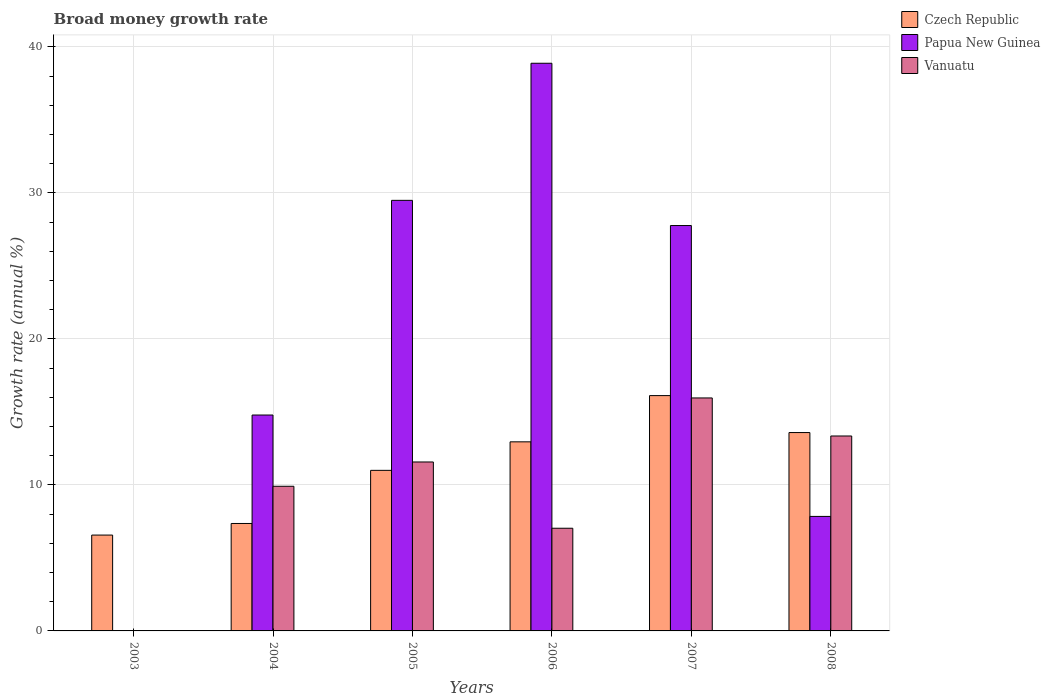Are the number of bars per tick equal to the number of legend labels?
Provide a short and direct response. No. Are the number of bars on each tick of the X-axis equal?
Offer a very short reply. No. How many bars are there on the 4th tick from the left?
Keep it short and to the point. 3. How many bars are there on the 5th tick from the right?
Keep it short and to the point. 3. What is the label of the 3rd group of bars from the left?
Provide a succinct answer. 2005. In how many cases, is the number of bars for a given year not equal to the number of legend labels?
Offer a very short reply. 1. What is the growth rate in Czech Republic in 2006?
Provide a succinct answer. 12.95. Across all years, what is the maximum growth rate in Czech Republic?
Make the answer very short. 16.12. Across all years, what is the minimum growth rate in Vanuatu?
Give a very brief answer. 0. What is the total growth rate in Papua New Guinea in the graph?
Offer a very short reply. 118.76. What is the difference between the growth rate in Vanuatu in 2004 and that in 2006?
Your answer should be very brief. 2.87. What is the difference between the growth rate in Papua New Guinea in 2007 and the growth rate in Czech Republic in 2005?
Make the answer very short. 16.77. What is the average growth rate in Papua New Guinea per year?
Offer a terse response. 19.79. In the year 2004, what is the difference between the growth rate in Vanuatu and growth rate in Czech Republic?
Your answer should be compact. 2.55. What is the ratio of the growth rate in Vanuatu in 2006 to that in 2008?
Give a very brief answer. 0.53. Is the difference between the growth rate in Vanuatu in 2005 and 2006 greater than the difference between the growth rate in Czech Republic in 2005 and 2006?
Ensure brevity in your answer.  Yes. What is the difference between the highest and the second highest growth rate in Papua New Guinea?
Make the answer very short. 9.39. What is the difference between the highest and the lowest growth rate in Czech Republic?
Your answer should be very brief. 9.55. In how many years, is the growth rate in Papua New Guinea greater than the average growth rate in Papua New Guinea taken over all years?
Your answer should be compact. 3. Is the sum of the growth rate in Papua New Guinea in 2005 and 2006 greater than the maximum growth rate in Vanuatu across all years?
Give a very brief answer. Yes. Is it the case that in every year, the sum of the growth rate in Vanuatu and growth rate in Czech Republic is greater than the growth rate in Papua New Guinea?
Ensure brevity in your answer.  No. Are all the bars in the graph horizontal?
Make the answer very short. No. What is the difference between two consecutive major ticks on the Y-axis?
Your answer should be compact. 10. Are the values on the major ticks of Y-axis written in scientific E-notation?
Your response must be concise. No. Does the graph contain grids?
Keep it short and to the point. Yes. How many legend labels are there?
Ensure brevity in your answer.  3. What is the title of the graph?
Keep it short and to the point. Broad money growth rate. What is the label or title of the Y-axis?
Your answer should be compact. Growth rate (annual %). What is the Growth rate (annual %) in Czech Republic in 2003?
Provide a short and direct response. 6.56. What is the Growth rate (annual %) of Papua New Guinea in 2003?
Provide a short and direct response. 0. What is the Growth rate (annual %) of Czech Republic in 2004?
Provide a short and direct response. 7.36. What is the Growth rate (annual %) in Papua New Guinea in 2004?
Ensure brevity in your answer.  14.79. What is the Growth rate (annual %) of Vanuatu in 2004?
Make the answer very short. 9.91. What is the Growth rate (annual %) in Czech Republic in 2005?
Your answer should be compact. 11. What is the Growth rate (annual %) in Papua New Guinea in 2005?
Give a very brief answer. 29.49. What is the Growth rate (annual %) of Vanuatu in 2005?
Give a very brief answer. 11.57. What is the Growth rate (annual %) of Czech Republic in 2006?
Give a very brief answer. 12.95. What is the Growth rate (annual %) of Papua New Guinea in 2006?
Make the answer very short. 38.88. What is the Growth rate (annual %) of Vanuatu in 2006?
Make the answer very short. 7.03. What is the Growth rate (annual %) in Czech Republic in 2007?
Make the answer very short. 16.12. What is the Growth rate (annual %) in Papua New Guinea in 2007?
Offer a terse response. 27.76. What is the Growth rate (annual %) in Vanuatu in 2007?
Offer a terse response. 15.96. What is the Growth rate (annual %) in Czech Republic in 2008?
Ensure brevity in your answer.  13.59. What is the Growth rate (annual %) of Papua New Guinea in 2008?
Provide a succinct answer. 7.84. What is the Growth rate (annual %) of Vanuatu in 2008?
Your response must be concise. 13.35. Across all years, what is the maximum Growth rate (annual %) of Czech Republic?
Ensure brevity in your answer.  16.12. Across all years, what is the maximum Growth rate (annual %) in Papua New Guinea?
Keep it short and to the point. 38.88. Across all years, what is the maximum Growth rate (annual %) in Vanuatu?
Your response must be concise. 15.96. Across all years, what is the minimum Growth rate (annual %) in Czech Republic?
Keep it short and to the point. 6.56. Across all years, what is the minimum Growth rate (annual %) in Papua New Guinea?
Your response must be concise. 0. Across all years, what is the minimum Growth rate (annual %) of Vanuatu?
Keep it short and to the point. 0. What is the total Growth rate (annual %) of Czech Republic in the graph?
Your response must be concise. 67.58. What is the total Growth rate (annual %) in Papua New Guinea in the graph?
Your answer should be compact. 118.76. What is the total Growth rate (annual %) of Vanuatu in the graph?
Give a very brief answer. 57.82. What is the difference between the Growth rate (annual %) in Czech Republic in 2003 and that in 2004?
Make the answer very short. -0.79. What is the difference between the Growth rate (annual %) in Czech Republic in 2003 and that in 2005?
Ensure brevity in your answer.  -4.43. What is the difference between the Growth rate (annual %) of Czech Republic in 2003 and that in 2006?
Your answer should be compact. -6.39. What is the difference between the Growth rate (annual %) of Czech Republic in 2003 and that in 2007?
Your response must be concise. -9.55. What is the difference between the Growth rate (annual %) of Czech Republic in 2003 and that in 2008?
Offer a very short reply. -7.02. What is the difference between the Growth rate (annual %) in Czech Republic in 2004 and that in 2005?
Provide a short and direct response. -3.64. What is the difference between the Growth rate (annual %) in Papua New Guinea in 2004 and that in 2005?
Offer a terse response. -14.7. What is the difference between the Growth rate (annual %) in Vanuatu in 2004 and that in 2005?
Provide a short and direct response. -1.66. What is the difference between the Growth rate (annual %) of Czech Republic in 2004 and that in 2006?
Provide a short and direct response. -5.59. What is the difference between the Growth rate (annual %) of Papua New Guinea in 2004 and that in 2006?
Ensure brevity in your answer.  -24.09. What is the difference between the Growth rate (annual %) of Vanuatu in 2004 and that in 2006?
Make the answer very short. 2.87. What is the difference between the Growth rate (annual %) of Czech Republic in 2004 and that in 2007?
Make the answer very short. -8.76. What is the difference between the Growth rate (annual %) of Papua New Guinea in 2004 and that in 2007?
Provide a short and direct response. -12.98. What is the difference between the Growth rate (annual %) of Vanuatu in 2004 and that in 2007?
Offer a very short reply. -6.05. What is the difference between the Growth rate (annual %) in Czech Republic in 2004 and that in 2008?
Your answer should be very brief. -6.23. What is the difference between the Growth rate (annual %) in Papua New Guinea in 2004 and that in 2008?
Give a very brief answer. 6.94. What is the difference between the Growth rate (annual %) in Vanuatu in 2004 and that in 2008?
Ensure brevity in your answer.  -3.44. What is the difference between the Growth rate (annual %) in Czech Republic in 2005 and that in 2006?
Offer a terse response. -1.95. What is the difference between the Growth rate (annual %) of Papua New Guinea in 2005 and that in 2006?
Make the answer very short. -9.39. What is the difference between the Growth rate (annual %) of Vanuatu in 2005 and that in 2006?
Give a very brief answer. 4.54. What is the difference between the Growth rate (annual %) in Czech Republic in 2005 and that in 2007?
Provide a succinct answer. -5.12. What is the difference between the Growth rate (annual %) of Papua New Guinea in 2005 and that in 2007?
Provide a succinct answer. 1.73. What is the difference between the Growth rate (annual %) of Vanuatu in 2005 and that in 2007?
Your answer should be very brief. -4.38. What is the difference between the Growth rate (annual %) of Czech Republic in 2005 and that in 2008?
Your answer should be very brief. -2.59. What is the difference between the Growth rate (annual %) in Papua New Guinea in 2005 and that in 2008?
Your answer should be compact. 21.65. What is the difference between the Growth rate (annual %) of Vanuatu in 2005 and that in 2008?
Offer a very short reply. -1.78. What is the difference between the Growth rate (annual %) of Czech Republic in 2006 and that in 2007?
Offer a very short reply. -3.17. What is the difference between the Growth rate (annual %) in Papua New Guinea in 2006 and that in 2007?
Give a very brief answer. 11.11. What is the difference between the Growth rate (annual %) in Vanuatu in 2006 and that in 2007?
Offer a very short reply. -8.92. What is the difference between the Growth rate (annual %) in Czech Republic in 2006 and that in 2008?
Your answer should be compact. -0.64. What is the difference between the Growth rate (annual %) of Papua New Guinea in 2006 and that in 2008?
Your answer should be very brief. 31.04. What is the difference between the Growth rate (annual %) in Vanuatu in 2006 and that in 2008?
Provide a succinct answer. -6.32. What is the difference between the Growth rate (annual %) in Czech Republic in 2007 and that in 2008?
Your answer should be compact. 2.53. What is the difference between the Growth rate (annual %) in Papua New Guinea in 2007 and that in 2008?
Your response must be concise. 19.92. What is the difference between the Growth rate (annual %) of Vanuatu in 2007 and that in 2008?
Your response must be concise. 2.61. What is the difference between the Growth rate (annual %) of Czech Republic in 2003 and the Growth rate (annual %) of Papua New Guinea in 2004?
Keep it short and to the point. -8.22. What is the difference between the Growth rate (annual %) in Czech Republic in 2003 and the Growth rate (annual %) in Vanuatu in 2004?
Keep it short and to the point. -3.34. What is the difference between the Growth rate (annual %) of Czech Republic in 2003 and the Growth rate (annual %) of Papua New Guinea in 2005?
Keep it short and to the point. -22.93. What is the difference between the Growth rate (annual %) of Czech Republic in 2003 and the Growth rate (annual %) of Vanuatu in 2005?
Keep it short and to the point. -5.01. What is the difference between the Growth rate (annual %) in Czech Republic in 2003 and the Growth rate (annual %) in Papua New Guinea in 2006?
Your response must be concise. -32.31. What is the difference between the Growth rate (annual %) of Czech Republic in 2003 and the Growth rate (annual %) of Vanuatu in 2006?
Your response must be concise. -0.47. What is the difference between the Growth rate (annual %) in Czech Republic in 2003 and the Growth rate (annual %) in Papua New Guinea in 2007?
Give a very brief answer. -21.2. What is the difference between the Growth rate (annual %) in Czech Republic in 2003 and the Growth rate (annual %) in Vanuatu in 2007?
Offer a terse response. -9.39. What is the difference between the Growth rate (annual %) in Czech Republic in 2003 and the Growth rate (annual %) in Papua New Guinea in 2008?
Give a very brief answer. -1.28. What is the difference between the Growth rate (annual %) of Czech Republic in 2003 and the Growth rate (annual %) of Vanuatu in 2008?
Provide a short and direct response. -6.79. What is the difference between the Growth rate (annual %) of Czech Republic in 2004 and the Growth rate (annual %) of Papua New Guinea in 2005?
Provide a short and direct response. -22.13. What is the difference between the Growth rate (annual %) of Czech Republic in 2004 and the Growth rate (annual %) of Vanuatu in 2005?
Ensure brevity in your answer.  -4.21. What is the difference between the Growth rate (annual %) of Papua New Guinea in 2004 and the Growth rate (annual %) of Vanuatu in 2005?
Offer a terse response. 3.22. What is the difference between the Growth rate (annual %) of Czech Republic in 2004 and the Growth rate (annual %) of Papua New Guinea in 2006?
Provide a short and direct response. -31.52. What is the difference between the Growth rate (annual %) in Czech Republic in 2004 and the Growth rate (annual %) in Vanuatu in 2006?
Your response must be concise. 0.33. What is the difference between the Growth rate (annual %) in Papua New Guinea in 2004 and the Growth rate (annual %) in Vanuatu in 2006?
Your answer should be very brief. 7.75. What is the difference between the Growth rate (annual %) of Czech Republic in 2004 and the Growth rate (annual %) of Papua New Guinea in 2007?
Offer a terse response. -20.41. What is the difference between the Growth rate (annual %) in Czech Republic in 2004 and the Growth rate (annual %) in Vanuatu in 2007?
Provide a short and direct response. -8.6. What is the difference between the Growth rate (annual %) of Papua New Guinea in 2004 and the Growth rate (annual %) of Vanuatu in 2007?
Keep it short and to the point. -1.17. What is the difference between the Growth rate (annual %) in Czech Republic in 2004 and the Growth rate (annual %) in Papua New Guinea in 2008?
Provide a short and direct response. -0.48. What is the difference between the Growth rate (annual %) of Czech Republic in 2004 and the Growth rate (annual %) of Vanuatu in 2008?
Ensure brevity in your answer.  -5.99. What is the difference between the Growth rate (annual %) in Papua New Guinea in 2004 and the Growth rate (annual %) in Vanuatu in 2008?
Your response must be concise. 1.44. What is the difference between the Growth rate (annual %) in Czech Republic in 2005 and the Growth rate (annual %) in Papua New Guinea in 2006?
Your answer should be very brief. -27.88. What is the difference between the Growth rate (annual %) in Czech Republic in 2005 and the Growth rate (annual %) in Vanuatu in 2006?
Your answer should be compact. 3.96. What is the difference between the Growth rate (annual %) of Papua New Guinea in 2005 and the Growth rate (annual %) of Vanuatu in 2006?
Your response must be concise. 22.46. What is the difference between the Growth rate (annual %) of Czech Republic in 2005 and the Growth rate (annual %) of Papua New Guinea in 2007?
Offer a terse response. -16.77. What is the difference between the Growth rate (annual %) of Czech Republic in 2005 and the Growth rate (annual %) of Vanuatu in 2007?
Give a very brief answer. -4.96. What is the difference between the Growth rate (annual %) of Papua New Guinea in 2005 and the Growth rate (annual %) of Vanuatu in 2007?
Your answer should be compact. 13.53. What is the difference between the Growth rate (annual %) of Czech Republic in 2005 and the Growth rate (annual %) of Papua New Guinea in 2008?
Offer a terse response. 3.15. What is the difference between the Growth rate (annual %) in Czech Republic in 2005 and the Growth rate (annual %) in Vanuatu in 2008?
Keep it short and to the point. -2.35. What is the difference between the Growth rate (annual %) of Papua New Guinea in 2005 and the Growth rate (annual %) of Vanuatu in 2008?
Provide a short and direct response. 16.14. What is the difference between the Growth rate (annual %) in Czech Republic in 2006 and the Growth rate (annual %) in Papua New Guinea in 2007?
Your answer should be very brief. -14.81. What is the difference between the Growth rate (annual %) in Czech Republic in 2006 and the Growth rate (annual %) in Vanuatu in 2007?
Keep it short and to the point. -3.01. What is the difference between the Growth rate (annual %) of Papua New Guinea in 2006 and the Growth rate (annual %) of Vanuatu in 2007?
Keep it short and to the point. 22.92. What is the difference between the Growth rate (annual %) in Czech Republic in 2006 and the Growth rate (annual %) in Papua New Guinea in 2008?
Keep it short and to the point. 5.11. What is the difference between the Growth rate (annual %) of Czech Republic in 2006 and the Growth rate (annual %) of Vanuatu in 2008?
Offer a terse response. -0.4. What is the difference between the Growth rate (annual %) of Papua New Guinea in 2006 and the Growth rate (annual %) of Vanuatu in 2008?
Offer a very short reply. 25.53. What is the difference between the Growth rate (annual %) of Czech Republic in 2007 and the Growth rate (annual %) of Papua New Guinea in 2008?
Make the answer very short. 8.27. What is the difference between the Growth rate (annual %) in Czech Republic in 2007 and the Growth rate (annual %) in Vanuatu in 2008?
Offer a very short reply. 2.77. What is the difference between the Growth rate (annual %) of Papua New Guinea in 2007 and the Growth rate (annual %) of Vanuatu in 2008?
Give a very brief answer. 14.41. What is the average Growth rate (annual %) of Czech Republic per year?
Your answer should be very brief. 11.26. What is the average Growth rate (annual %) in Papua New Guinea per year?
Provide a succinct answer. 19.79. What is the average Growth rate (annual %) of Vanuatu per year?
Offer a very short reply. 9.64. In the year 2004, what is the difference between the Growth rate (annual %) of Czech Republic and Growth rate (annual %) of Papua New Guinea?
Your answer should be very brief. -7.43. In the year 2004, what is the difference between the Growth rate (annual %) in Czech Republic and Growth rate (annual %) in Vanuatu?
Ensure brevity in your answer.  -2.55. In the year 2004, what is the difference between the Growth rate (annual %) of Papua New Guinea and Growth rate (annual %) of Vanuatu?
Keep it short and to the point. 4.88. In the year 2005, what is the difference between the Growth rate (annual %) in Czech Republic and Growth rate (annual %) in Papua New Guinea?
Give a very brief answer. -18.49. In the year 2005, what is the difference between the Growth rate (annual %) of Czech Republic and Growth rate (annual %) of Vanuatu?
Make the answer very short. -0.57. In the year 2005, what is the difference between the Growth rate (annual %) in Papua New Guinea and Growth rate (annual %) in Vanuatu?
Ensure brevity in your answer.  17.92. In the year 2006, what is the difference between the Growth rate (annual %) in Czech Republic and Growth rate (annual %) in Papua New Guinea?
Your response must be concise. -25.93. In the year 2006, what is the difference between the Growth rate (annual %) in Czech Republic and Growth rate (annual %) in Vanuatu?
Give a very brief answer. 5.92. In the year 2006, what is the difference between the Growth rate (annual %) in Papua New Guinea and Growth rate (annual %) in Vanuatu?
Ensure brevity in your answer.  31.85. In the year 2007, what is the difference between the Growth rate (annual %) of Czech Republic and Growth rate (annual %) of Papua New Guinea?
Your answer should be compact. -11.65. In the year 2007, what is the difference between the Growth rate (annual %) of Czech Republic and Growth rate (annual %) of Vanuatu?
Your answer should be compact. 0.16. In the year 2007, what is the difference between the Growth rate (annual %) of Papua New Guinea and Growth rate (annual %) of Vanuatu?
Ensure brevity in your answer.  11.81. In the year 2008, what is the difference between the Growth rate (annual %) of Czech Republic and Growth rate (annual %) of Papua New Guinea?
Offer a very short reply. 5.74. In the year 2008, what is the difference between the Growth rate (annual %) in Czech Republic and Growth rate (annual %) in Vanuatu?
Your response must be concise. 0.23. In the year 2008, what is the difference between the Growth rate (annual %) of Papua New Guinea and Growth rate (annual %) of Vanuatu?
Your answer should be very brief. -5.51. What is the ratio of the Growth rate (annual %) of Czech Republic in 2003 to that in 2004?
Make the answer very short. 0.89. What is the ratio of the Growth rate (annual %) in Czech Republic in 2003 to that in 2005?
Provide a succinct answer. 0.6. What is the ratio of the Growth rate (annual %) of Czech Republic in 2003 to that in 2006?
Make the answer very short. 0.51. What is the ratio of the Growth rate (annual %) in Czech Republic in 2003 to that in 2007?
Ensure brevity in your answer.  0.41. What is the ratio of the Growth rate (annual %) of Czech Republic in 2003 to that in 2008?
Your response must be concise. 0.48. What is the ratio of the Growth rate (annual %) of Czech Republic in 2004 to that in 2005?
Offer a terse response. 0.67. What is the ratio of the Growth rate (annual %) in Papua New Guinea in 2004 to that in 2005?
Offer a very short reply. 0.5. What is the ratio of the Growth rate (annual %) of Vanuatu in 2004 to that in 2005?
Provide a short and direct response. 0.86. What is the ratio of the Growth rate (annual %) in Czech Republic in 2004 to that in 2006?
Ensure brevity in your answer.  0.57. What is the ratio of the Growth rate (annual %) in Papua New Guinea in 2004 to that in 2006?
Make the answer very short. 0.38. What is the ratio of the Growth rate (annual %) in Vanuatu in 2004 to that in 2006?
Keep it short and to the point. 1.41. What is the ratio of the Growth rate (annual %) in Czech Republic in 2004 to that in 2007?
Your answer should be compact. 0.46. What is the ratio of the Growth rate (annual %) in Papua New Guinea in 2004 to that in 2007?
Offer a terse response. 0.53. What is the ratio of the Growth rate (annual %) of Vanuatu in 2004 to that in 2007?
Keep it short and to the point. 0.62. What is the ratio of the Growth rate (annual %) in Czech Republic in 2004 to that in 2008?
Offer a very short reply. 0.54. What is the ratio of the Growth rate (annual %) of Papua New Guinea in 2004 to that in 2008?
Keep it short and to the point. 1.89. What is the ratio of the Growth rate (annual %) of Vanuatu in 2004 to that in 2008?
Your answer should be compact. 0.74. What is the ratio of the Growth rate (annual %) in Czech Republic in 2005 to that in 2006?
Your answer should be very brief. 0.85. What is the ratio of the Growth rate (annual %) in Papua New Guinea in 2005 to that in 2006?
Keep it short and to the point. 0.76. What is the ratio of the Growth rate (annual %) in Vanuatu in 2005 to that in 2006?
Provide a short and direct response. 1.65. What is the ratio of the Growth rate (annual %) in Czech Republic in 2005 to that in 2007?
Your answer should be compact. 0.68. What is the ratio of the Growth rate (annual %) in Papua New Guinea in 2005 to that in 2007?
Ensure brevity in your answer.  1.06. What is the ratio of the Growth rate (annual %) of Vanuatu in 2005 to that in 2007?
Offer a very short reply. 0.73. What is the ratio of the Growth rate (annual %) in Czech Republic in 2005 to that in 2008?
Make the answer very short. 0.81. What is the ratio of the Growth rate (annual %) of Papua New Guinea in 2005 to that in 2008?
Give a very brief answer. 3.76. What is the ratio of the Growth rate (annual %) in Vanuatu in 2005 to that in 2008?
Keep it short and to the point. 0.87. What is the ratio of the Growth rate (annual %) of Czech Republic in 2006 to that in 2007?
Offer a very short reply. 0.8. What is the ratio of the Growth rate (annual %) of Papua New Guinea in 2006 to that in 2007?
Ensure brevity in your answer.  1.4. What is the ratio of the Growth rate (annual %) of Vanuatu in 2006 to that in 2007?
Ensure brevity in your answer.  0.44. What is the ratio of the Growth rate (annual %) in Czech Republic in 2006 to that in 2008?
Offer a terse response. 0.95. What is the ratio of the Growth rate (annual %) in Papua New Guinea in 2006 to that in 2008?
Provide a succinct answer. 4.96. What is the ratio of the Growth rate (annual %) in Vanuatu in 2006 to that in 2008?
Your answer should be very brief. 0.53. What is the ratio of the Growth rate (annual %) of Czech Republic in 2007 to that in 2008?
Your answer should be very brief. 1.19. What is the ratio of the Growth rate (annual %) in Papua New Guinea in 2007 to that in 2008?
Provide a short and direct response. 3.54. What is the ratio of the Growth rate (annual %) in Vanuatu in 2007 to that in 2008?
Your answer should be compact. 1.2. What is the difference between the highest and the second highest Growth rate (annual %) in Czech Republic?
Keep it short and to the point. 2.53. What is the difference between the highest and the second highest Growth rate (annual %) in Papua New Guinea?
Your answer should be compact. 9.39. What is the difference between the highest and the second highest Growth rate (annual %) of Vanuatu?
Give a very brief answer. 2.61. What is the difference between the highest and the lowest Growth rate (annual %) of Czech Republic?
Your response must be concise. 9.55. What is the difference between the highest and the lowest Growth rate (annual %) of Papua New Guinea?
Give a very brief answer. 38.88. What is the difference between the highest and the lowest Growth rate (annual %) in Vanuatu?
Keep it short and to the point. 15.96. 